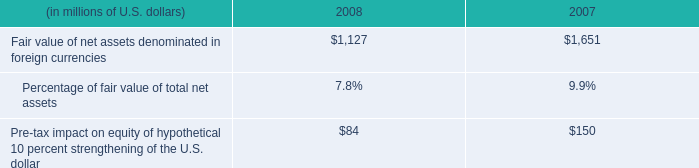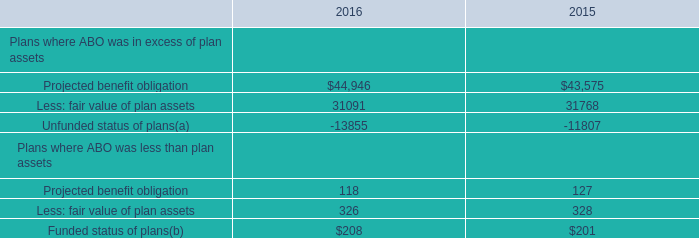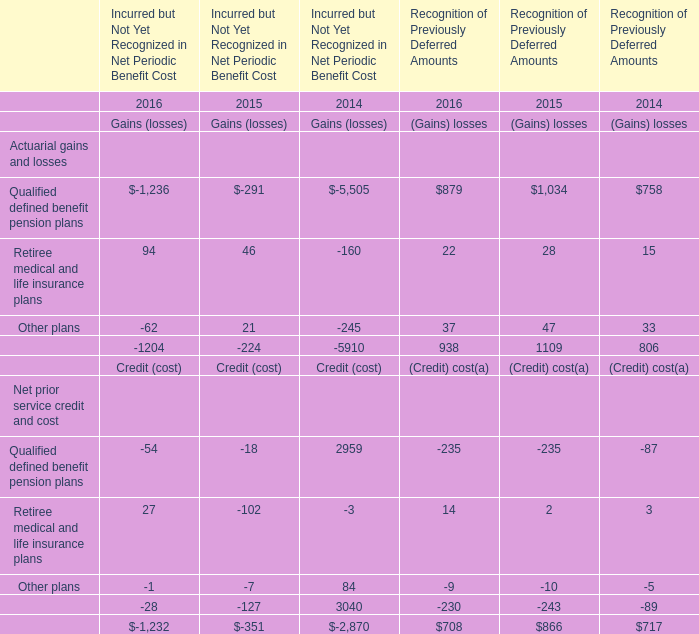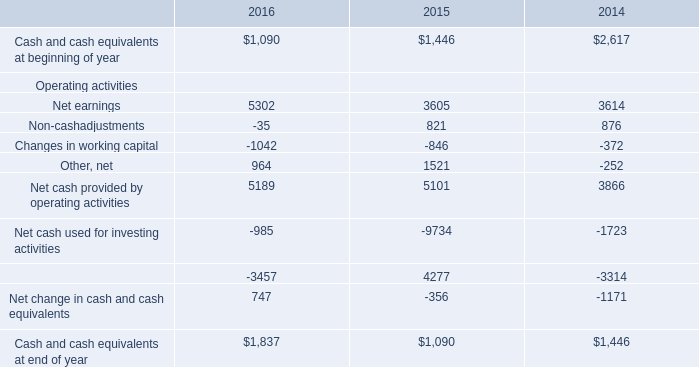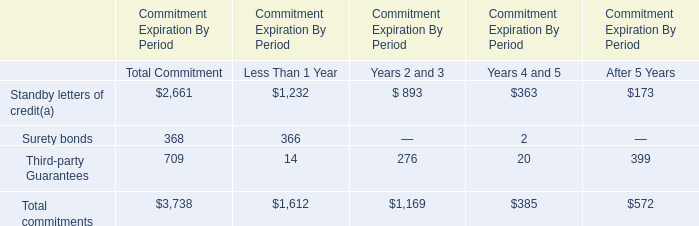What is the average amount of Net cash used for investing activities Operating activities of 2014, and Projected benefit obligation of 2016 ? 
Computations: ((1723.0 + 44946.0) / 2)
Answer: 23334.5. 